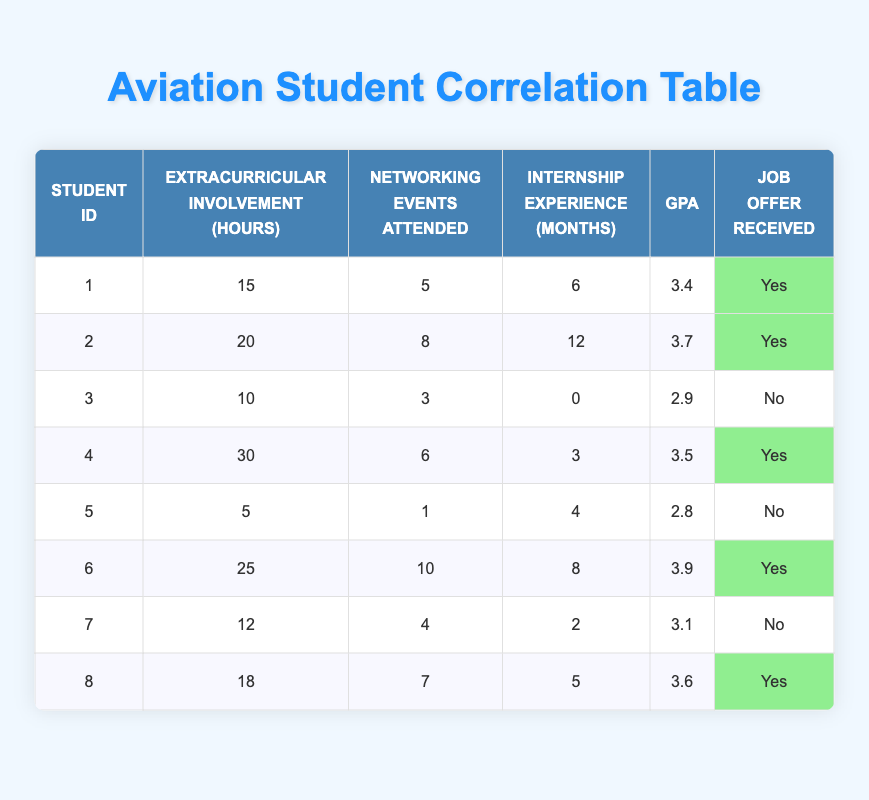What is the GPA of the student who attended the most networking events? Student 6 attended 10 networking events and has a GPA of 3.9, which is the highest GPA among students with the most attended events.
Answer: 3.9 Which student has the least extracurricular involvement hours and did not receive a job offer? Student 5 has the least extracurricular involvement with 5 hours and did not receive a job offer.
Answer: Student 5 What is the average number of internship experience months for students who received job offers? The students who received job offers are 1 (6 months), 2 (12 months), 4 (3 months), 6 (8 months), and 8 (5 months). The total is 6 + 12 + 3 + 8 + 5 = 34 months, and there are 5 students, so the average is 34/5 = 6.8 months.
Answer: 6.8 Do students with a GPA of 3.5 or higher all receive job offers? Students 2 (3.7), 4 (3.5), 6 (3.9), and 8 (3.6) all received job offers, confirming that they have a GPA of 3.5 or higher.
Answer: Yes How many students with more than 20 extracurricular involvement hours received job offers? Student 2 (20 hours), 4 (30 hours), and 6 (25 hours) are the relevant students. All three received job offers. Thus, the total is 3 students.
Answer: 3 Which student has a GPA of 2.8 and what was their involvement in networking events? Student 5 has a GPA of 2.8 and attended 1 networking event.
Answer: Student 5, 1 event What is the difference between the highest and lowest number of networking events attended? The highest number of networking events attended is 10 (Student 6) and the lowest is 1 (Student 5). Thus, 10 - 1 = 9 is the difference.
Answer: 9 Are there more students with internship experience of 6 months or less that received a job offer? Students with 6 months or less of internship experience who received job offers are Students 1 (6 months) and 4 (3 months). Therefore, there are 2 such students.
Answer: Yes What percentage of students with extracurricular involvement hours under 15 received job offers? Students with less than 15 hours are Students 3 (10 hours) and 5 (5 hours). Only Student 5 did not receive a job offer. Thus, 1 out of 2 received offers, so the percentage is (1/2)*100 = 50%.
Answer: 50 